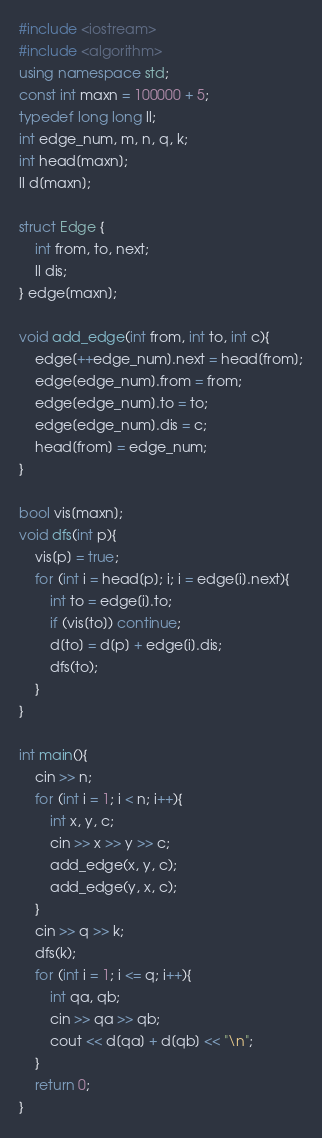Convert code to text. <code><loc_0><loc_0><loc_500><loc_500><_C++_>#include <iostream>
#include <algorithm>
using namespace std;
const int maxn = 100000 + 5;
typedef long long ll;
int edge_num, m, n, q, k;
int head[maxn];
ll d[maxn];

struct Edge {
	int from, to, next;
   	ll dis;
} edge[maxn];

void add_edge(int from, int to, int c){
	edge[++edge_num].next = head[from];
	edge[edge_num].from = from;
	edge[edge_num].to = to;
	edge[edge_num].dis = c;
	head[from] = edge_num;
}

bool vis[maxn];
void dfs(int p){
	vis[p] = true;
	for (int i = head[p]; i; i = edge[i].next){
		int to = edge[i].to;
		if (vis[to]) continue;
		d[to] = d[p] + edge[i].dis;
		dfs(to);	
	}
}

int main(){
	cin >> n;
	for (int i = 1; i < n; i++){
		int x, y, c;
		cin >> x >> y >> c;
		add_edge(x, y, c);
		add_edge(y, x, c);
	}
	cin >> q >> k;
	dfs(k);
	for (int i = 1; i <= q; i++){
		int qa, qb;
		cin >> qa >> qb;
		cout << d[qa] + d[qb] << "\n";
	}
	return 0;
}

</code> 